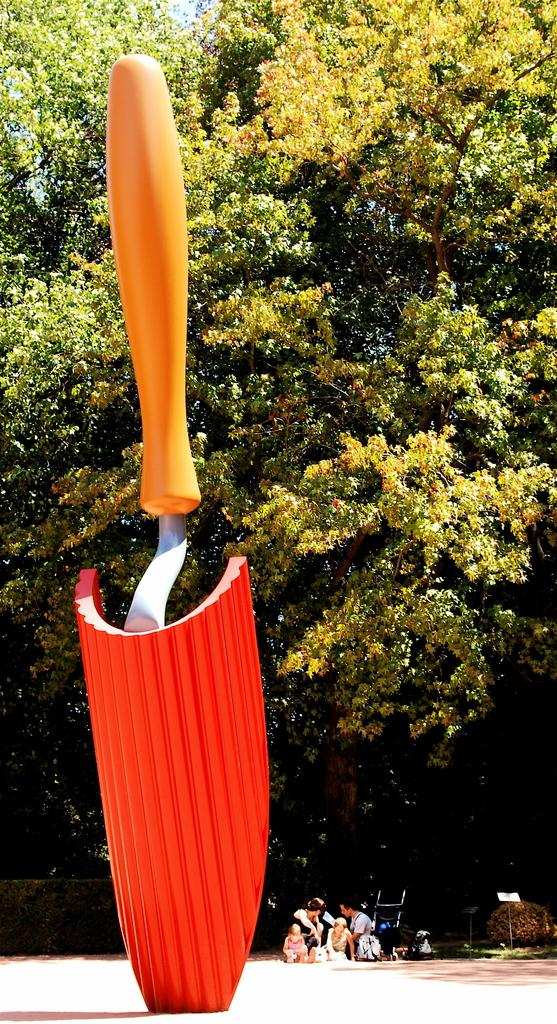What is the main subject in the image? There is a statue in the image. What is located behind the statue? There are people on the ground behind the statue. What type of barrier can be seen in the image? There is a fence visible in the image. What type of vegetation is present in the image? There are plants and a group of trees in the image. What part of the natural environment is visible in the image? The sky is visible in the image. What type of bubble can be seen floating around the statue in the image? There is no bubble present in the image; it only features a statue, people, fence, plants, trees, and the sky. 